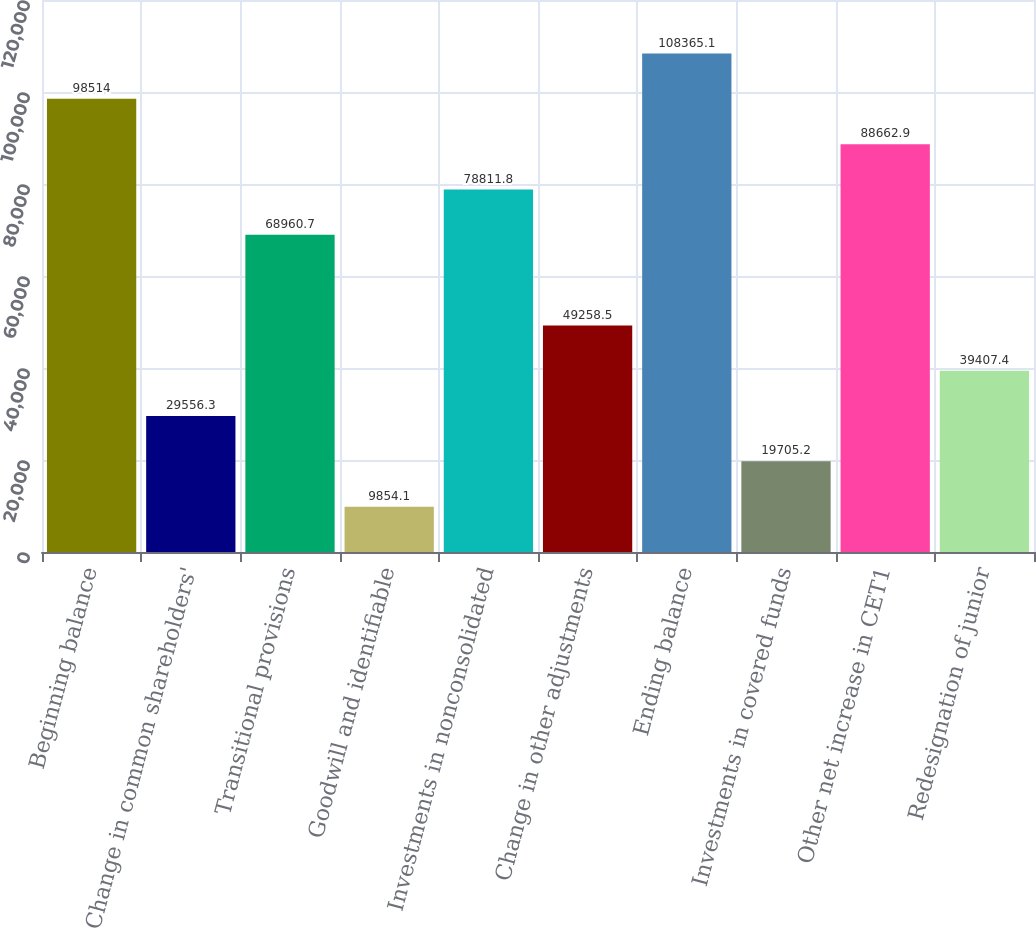<chart> <loc_0><loc_0><loc_500><loc_500><bar_chart><fcel>Beginning balance<fcel>Change in common shareholders'<fcel>Transitional provisions<fcel>Goodwill and identifiable<fcel>Investments in nonconsolidated<fcel>Change in other adjustments<fcel>Ending balance<fcel>Investments in covered funds<fcel>Other net increase in CET1<fcel>Redesignation of junior<nl><fcel>98514<fcel>29556.3<fcel>68960.7<fcel>9854.1<fcel>78811.8<fcel>49258.5<fcel>108365<fcel>19705.2<fcel>88662.9<fcel>39407.4<nl></chart> 